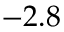<formula> <loc_0><loc_0><loc_500><loc_500>- 2 . 8</formula> 